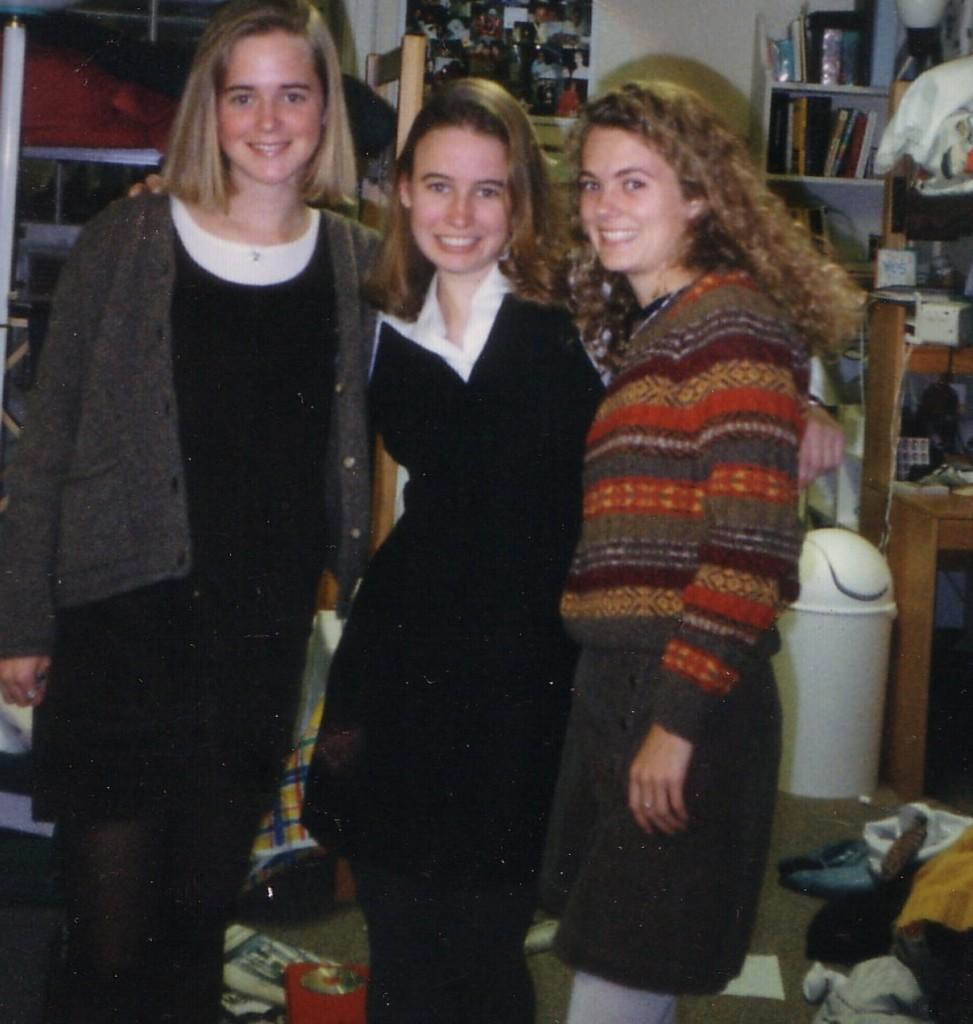How many people are in the image? There are three ladies in the image. What are the ladies doing in the image? The ladies are standing and holding each other. Can you describe any other objects or features visible in the image? There are other objects visible in the background, but their specific details are not mentioned in the provided facts. What type of peace symbol can be seen in the image? There is no peace symbol present in the image. Can you tell me how many knives are visible in the image? There is no knife present in the image. 